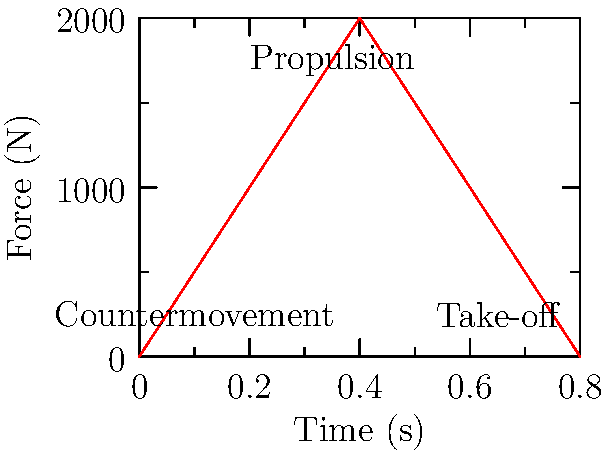In the force-time curve shown for a basketball player's vertical leap, what is the approximate peak force generated during the propulsion phase, and how might this relate to the player's jumping ability? To answer this question, we need to analyze the force-time curve:

1. Identify the phases of the jump:
   - Countermovement: 0-0.2s (initial dip in force)
   - Propulsion: 0.2-0.5s (rapid increase and peak in force)
   - Take-off: 0.5-0.8s (decrease in force to zero)

2. Locate the peak force:
   - The highest point on the curve occurs during the propulsion phase
   - This peak is at approximately 2000 N

3. Relate peak force to jumping ability:
   - Higher peak force generally correlates with greater jumping ability
   - Force = mass × acceleration, so more force means more acceleration
   - Greater acceleration leads to higher vertical velocity at take-off
   - Higher take-off velocity results in a higher vertical jump

4. Consider other factors:
   - Rate of force development (steepness of curve) also impacts jump height
   - Duration of force application affects impulse, which determines take-off velocity
   - Body weight and technique influence overall jump performance

5. Application to basketball:
   - Players with higher peak forces may have an advantage in rebounding and shot-blocking
   - Strength and power training to increase peak force can improve vertical jump performance
Answer: Peak force: ~2000 N; Higher peak force generally indicates greater jumping ability, potentially improving rebounding and shot-blocking performance. 